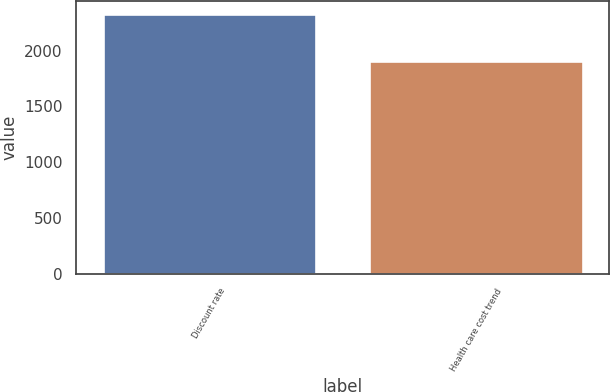Convert chart. <chart><loc_0><loc_0><loc_500><loc_500><bar_chart><fcel>Discount rate<fcel>Health care cost trend<nl><fcel>2334<fcel>1909<nl></chart> 